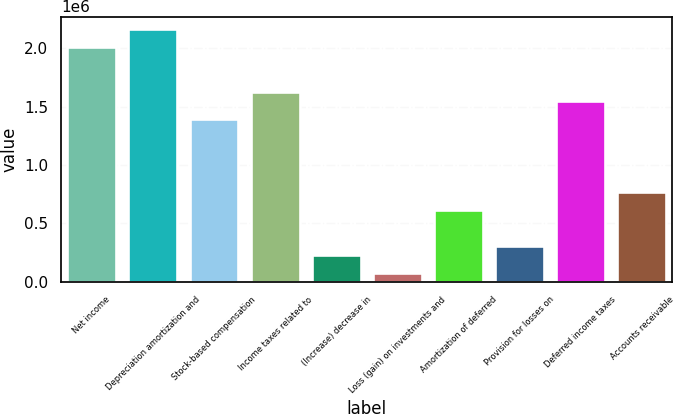Convert chart. <chart><loc_0><loc_0><loc_500><loc_500><bar_chart><fcel>Net income<fcel>Depreciation amortization and<fcel>Stock-based compensation<fcel>Income taxes related to<fcel>(Increase) decrease in<fcel>Loss (gain) on investments and<fcel>Amortization of deferred<fcel>Provision for losses on<fcel>Deferred income taxes<fcel>Accounts receivable<nl><fcel>2.01016e+06<fcel>2.16478e+06<fcel>1.39171e+06<fcel>1.62363e+06<fcel>232112<fcel>77498.6<fcel>618645<fcel>309418<fcel>1.54632e+06<fcel>773258<nl></chart> 